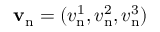Convert formula to latex. <formula><loc_0><loc_0><loc_500><loc_500>{ v } _ { n } = ( v _ { n } ^ { 1 } , v _ { n } ^ { 2 } , v _ { n } ^ { 3 } )</formula> 